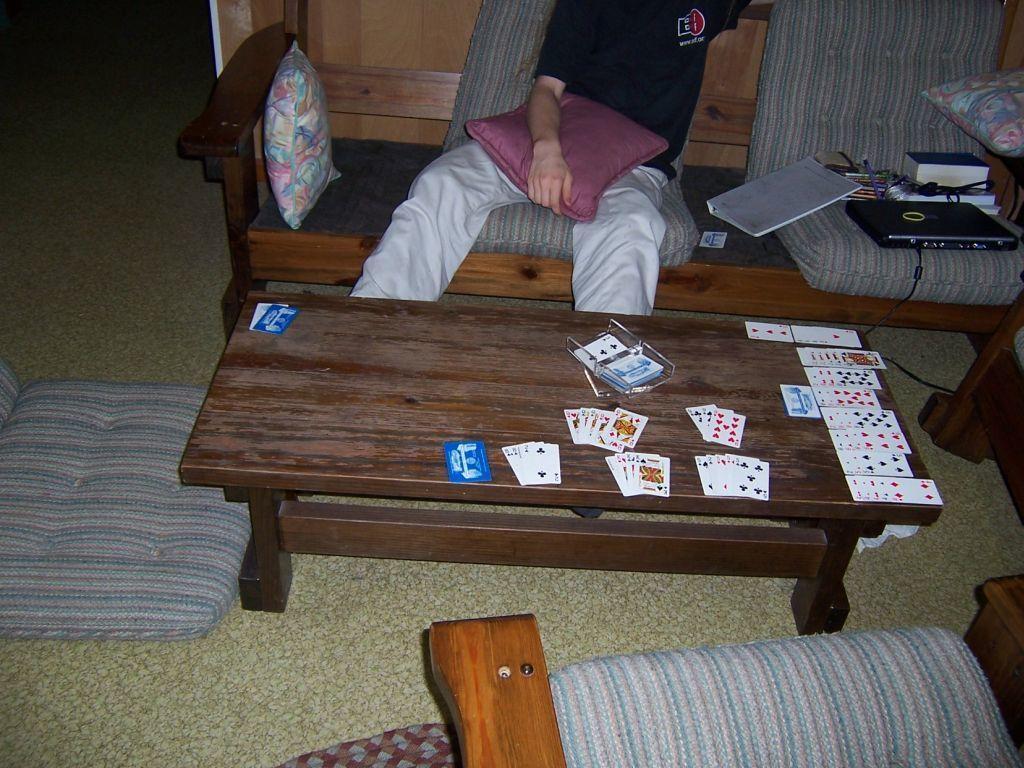Please provide a concise description of this image. In this image I see a person who is sitting on soda and he is holding a cushion and I can also see there are few books, a laptop and other things near to him. In front there is a table on which there are cards and I can also see another sofa over here. 